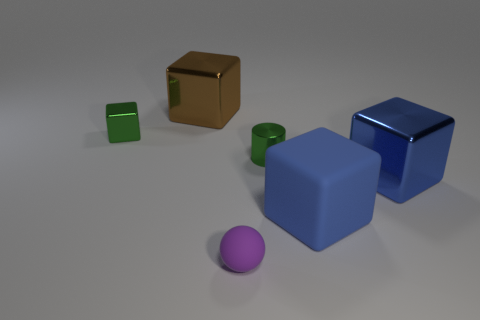How many small blue balls are there?
Your answer should be compact. 0. Are the large brown cube and the large blue thing left of the big blue shiny block made of the same material?
Your response must be concise. No. There is a thing behind the small green shiny block; is it the same color as the small rubber object?
Give a very brief answer. No. There is a small object that is behind the blue metal block and to the right of the green cube; what is it made of?
Offer a very short reply. Metal. How big is the green shiny block?
Your answer should be very brief. Small. Do the small metallic cylinder and the big object to the left of the large matte block have the same color?
Your answer should be very brief. No. What number of other objects are the same color as the small rubber sphere?
Your response must be concise. 0. Is the size of the object that is on the right side of the large rubber block the same as the rubber object that is behind the purple matte ball?
Your answer should be compact. Yes. The big shiny cube that is left of the tiny purple matte thing is what color?
Make the answer very short. Brown. Is the number of small metal cubes that are right of the small green cylinder less than the number of large gray rubber blocks?
Ensure brevity in your answer.  No. 